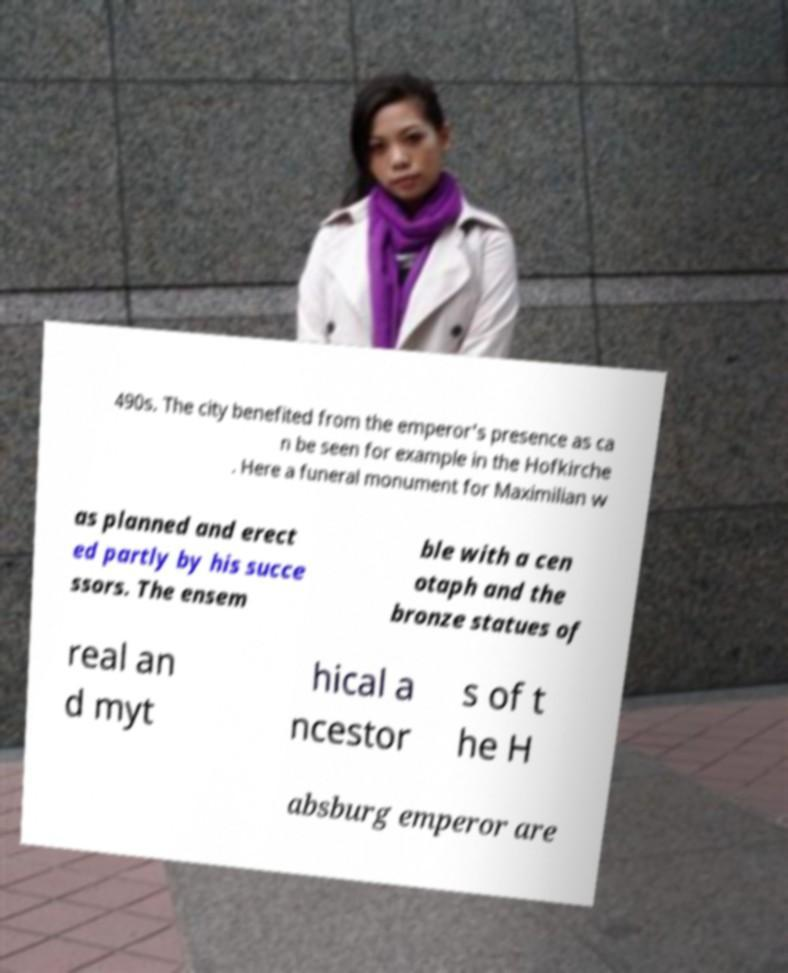Please identify and transcribe the text found in this image. 490s. The city benefited from the emperor's presence as ca n be seen for example in the Hofkirche . Here a funeral monument for Maximilian w as planned and erect ed partly by his succe ssors. The ensem ble with a cen otaph and the bronze statues of real an d myt hical a ncestor s of t he H absburg emperor are 